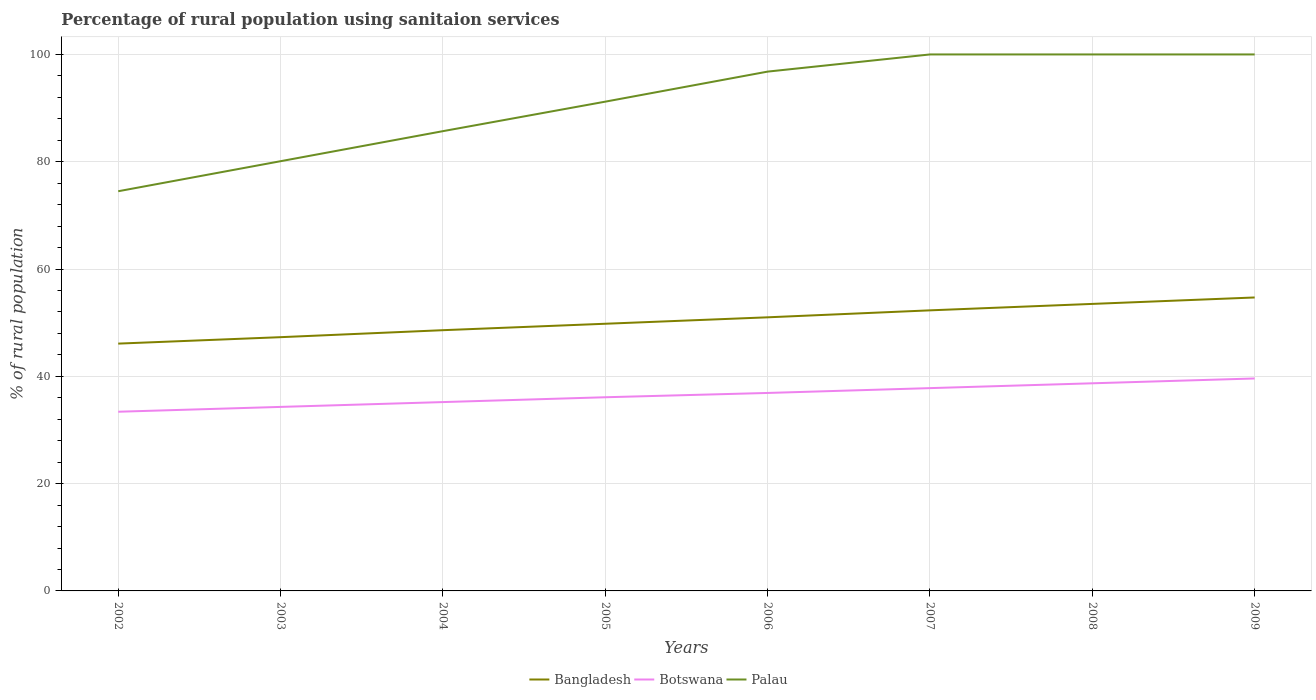How many different coloured lines are there?
Provide a succinct answer. 3. Is the number of lines equal to the number of legend labels?
Ensure brevity in your answer.  Yes. Across all years, what is the maximum percentage of rural population using sanitaion services in Bangladesh?
Provide a short and direct response. 46.1. In which year was the percentage of rural population using sanitaion services in Bangladesh maximum?
Offer a terse response. 2002. What is the total percentage of rural population using sanitaion services in Palau in the graph?
Your answer should be compact. -14.3. What is the difference between the highest and the lowest percentage of rural population using sanitaion services in Botswana?
Give a very brief answer. 4. Is the percentage of rural population using sanitaion services in Palau strictly greater than the percentage of rural population using sanitaion services in Bangladesh over the years?
Your answer should be very brief. No. Does the graph contain any zero values?
Offer a terse response. No. Where does the legend appear in the graph?
Your answer should be compact. Bottom center. How many legend labels are there?
Your answer should be very brief. 3. How are the legend labels stacked?
Offer a terse response. Horizontal. What is the title of the graph?
Your answer should be compact. Percentage of rural population using sanitaion services. Does "Ethiopia" appear as one of the legend labels in the graph?
Offer a very short reply. No. What is the label or title of the X-axis?
Keep it short and to the point. Years. What is the label or title of the Y-axis?
Offer a very short reply. % of rural population. What is the % of rural population of Bangladesh in 2002?
Offer a very short reply. 46.1. What is the % of rural population of Botswana in 2002?
Provide a succinct answer. 33.4. What is the % of rural population of Palau in 2002?
Your answer should be very brief. 74.5. What is the % of rural population of Bangladesh in 2003?
Your response must be concise. 47.3. What is the % of rural population of Botswana in 2003?
Give a very brief answer. 34.3. What is the % of rural population in Palau in 2003?
Provide a short and direct response. 80.1. What is the % of rural population of Bangladesh in 2004?
Your answer should be compact. 48.6. What is the % of rural population in Botswana in 2004?
Make the answer very short. 35.2. What is the % of rural population in Palau in 2004?
Provide a short and direct response. 85.7. What is the % of rural population in Bangladesh in 2005?
Provide a short and direct response. 49.8. What is the % of rural population of Botswana in 2005?
Your answer should be very brief. 36.1. What is the % of rural population in Palau in 2005?
Give a very brief answer. 91.2. What is the % of rural population of Botswana in 2006?
Your answer should be compact. 36.9. What is the % of rural population of Palau in 2006?
Your answer should be compact. 96.8. What is the % of rural population of Bangladesh in 2007?
Your answer should be compact. 52.3. What is the % of rural population in Botswana in 2007?
Give a very brief answer. 37.8. What is the % of rural population in Bangladesh in 2008?
Give a very brief answer. 53.5. What is the % of rural population in Botswana in 2008?
Give a very brief answer. 38.7. What is the % of rural population of Bangladesh in 2009?
Ensure brevity in your answer.  54.7. What is the % of rural population of Botswana in 2009?
Offer a very short reply. 39.6. Across all years, what is the maximum % of rural population in Bangladesh?
Ensure brevity in your answer.  54.7. Across all years, what is the maximum % of rural population of Botswana?
Provide a short and direct response. 39.6. Across all years, what is the minimum % of rural population in Bangladesh?
Your answer should be very brief. 46.1. Across all years, what is the minimum % of rural population of Botswana?
Ensure brevity in your answer.  33.4. Across all years, what is the minimum % of rural population of Palau?
Make the answer very short. 74.5. What is the total % of rural population in Bangladesh in the graph?
Give a very brief answer. 403.3. What is the total % of rural population in Botswana in the graph?
Keep it short and to the point. 292. What is the total % of rural population of Palau in the graph?
Provide a succinct answer. 728.3. What is the difference between the % of rural population in Bangladesh in 2002 and that in 2003?
Keep it short and to the point. -1.2. What is the difference between the % of rural population of Botswana in 2002 and that in 2003?
Keep it short and to the point. -0.9. What is the difference between the % of rural population in Palau in 2002 and that in 2003?
Offer a very short reply. -5.6. What is the difference between the % of rural population in Palau in 2002 and that in 2004?
Your response must be concise. -11.2. What is the difference between the % of rural population in Palau in 2002 and that in 2005?
Provide a succinct answer. -16.7. What is the difference between the % of rural population of Bangladesh in 2002 and that in 2006?
Offer a terse response. -4.9. What is the difference between the % of rural population of Botswana in 2002 and that in 2006?
Provide a short and direct response. -3.5. What is the difference between the % of rural population of Palau in 2002 and that in 2006?
Make the answer very short. -22.3. What is the difference between the % of rural population of Botswana in 2002 and that in 2007?
Your answer should be compact. -4.4. What is the difference between the % of rural population of Palau in 2002 and that in 2007?
Your response must be concise. -25.5. What is the difference between the % of rural population in Palau in 2002 and that in 2008?
Provide a succinct answer. -25.5. What is the difference between the % of rural population of Botswana in 2002 and that in 2009?
Provide a succinct answer. -6.2. What is the difference between the % of rural population of Palau in 2002 and that in 2009?
Your response must be concise. -25.5. What is the difference between the % of rural population in Bangladesh in 2003 and that in 2004?
Give a very brief answer. -1.3. What is the difference between the % of rural population of Bangladesh in 2003 and that in 2005?
Ensure brevity in your answer.  -2.5. What is the difference between the % of rural population in Botswana in 2003 and that in 2005?
Give a very brief answer. -1.8. What is the difference between the % of rural population in Palau in 2003 and that in 2005?
Keep it short and to the point. -11.1. What is the difference between the % of rural population of Palau in 2003 and that in 2006?
Provide a succinct answer. -16.7. What is the difference between the % of rural population of Botswana in 2003 and that in 2007?
Your answer should be compact. -3.5. What is the difference between the % of rural population in Palau in 2003 and that in 2007?
Provide a short and direct response. -19.9. What is the difference between the % of rural population of Botswana in 2003 and that in 2008?
Your response must be concise. -4.4. What is the difference between the % of rural population in Palau in 2003 and that in 2008?
Your answer should be compact. -19.9. What is the difference between the % of rural population in Bangladesh in 2003 and that in 2009?
Your answer should be compact. -7.4. What is the difference between the % of rural population of Palau in 2003 and that in 2009?
Provide a short and direct response. -19.9. What is the difference between the % of rural population in Botswana in 2004 and that in 2005?
Your answer should be very brief. -0.9. What is the difference between the % of rural population of Palau in 2004 and that in 2006?
Ensure brevity in your answer.  -11.1. What is the difference between the % of rural population of Bangladesh in 2004 and that in 2007?
Provide a short and direct response. -3.7. What is the difference between the % of rural population in Botswana in 2004 and that in 2007?
Your response must be concise. -2.6. What is the difference between the % of rural population in Palau in 2004 and that in 2007?
Your answer should be very brief. -14.3. What is the difference between the % of rural population in Bangladesh in 2004 and that in 2008?
Offer a very short reply. -4.9. What is the difference between the % of rural population in Palau in 2004 and that in 2008?
Offer a terse response. -14.3. What is the difference between the % of rural population of Bangladesh in 2004 and that in 2009?
Make the answer very short. -6.1. What is the difference between the % of rural population of Botswana in 2004 and that in 2009?
Give a very brief answer. -4.4. What is the difference between the % of rural population in Palau in 2004 and that in 2009?
Provide a short and direct response. -14.3. What is the difference between the % of rural population of Botswana in 2005 and that in 2006?
Your answer should be compact. -0.8. What is the difference between the % of rural population in Palau in 2005 and that in 2007?
Your answer should be very brief. -8.8. What is the difference between the % of rural population in Bangladesh in 2005 and that in 2008?
Make the answer very short. -3.7. What is the difference between the % of rural population in Botswana in 2005 and that in 2008?
Provide a short and direct response. -2.6. What is the difference between the % of rural population of Palau in 2005 and that in 2008?
Your answer should be compact. -8.8. What is the difference between the % of rural population in Botswana in 2005 and that in 2009?
Offer a very short reply. -3.5. What is the difference between the % of rural population of Palau in 2005 and that in 2009?
Give a very brief answer. -8.8. What is the difference between the % of rural population in Botswana in 2006 and that in 2007?
Provide a succinct answer. -0.9. What is the difference between the % of rural population in Botswana in 2006 and that in 2009?
Provide a succinct answer. -2.7. What is the difference between the % of rural population in Palau in 2006 and that in 2009?
Offer a terse response. -3.2. What is the difference between the % of rural population of Botswana in 2007 and that in 2008?
Offer a terse response. -0.9. What is the difference between the % of rural population of Palau in 2007 and that in 2008?
Ensure brevity in your answer.  0. What is the difference between the % of rural population of Bangladesh in 2002 and the % of rural population of Palau in 2003?
Provide a short and direct response. -34. What is the difference between the % of rural population of Botswana in 2002 and the % of rural population of Palau in 2003?
Provide a succinct answer. -46.7. What is the difference between the % of rural population in Bangladesh in 2002 and the % of rural population in Palau in 2004?
Provide a succinct answer. -39.6. What is the difference between the % of rural population in Botswana in 2002 and the % of rural population in Palau in 2004?
Keep it short and to the point. -52.3. What is the difference between the % of rural population in Bangladesh in 2002 and the % of rural population in Botswana in 2005?
Offer a very short reply. 10. What is the difference between the % of rural population in Bangladesh in 2002 and the % of rural population in Palau in 2005?
Give a very brief answer. -45.1. What is the difference between the % of rural population of Botswana in 2002 and the % of rural population of Palau in 2005?
Ensure brevity in your answer.  -57.8. What is the difference between the % of rural population of Bangladesh in 2002 and the % of rural population of Palau in 2006?
Your response must be concise. -50.7. What is the difference between the % of rural population of Botswana in 2002 and the % of rural population of Palau in 2006?
Your answer should be very brief. -63.4. What is the difference between the % of rural population in Bangladesh in 2002 and the % of rural population in Palau in 2007?
Your answer should be very brief. -53.9. What is the difference between the % of rural population in Botswana in 2002 and the % of rural population in Palau in 2007?
Provide a short and direct response. -66.6. What is the difference between the % of rural population in Bangladesh in 2002 and the % of rural population in Palau in 2008?
Keep it short and to the point. -53.9. What is the difference between the % of rural population of Botswana in 2002 and the % of rural population of Palau in 2008?
Provide a succinct answer. -66.6. What is the difference between the % of rural population in Bangladesh in 2002 and the % of rural population in Palau in 2009?
Give a very brief answer. -53.9. What is the difference between the % of rural population of Botswana in 2002 and the % of rural population of Palau in 2009?
Ensure brevity in your answer.  -66.6. What is the difference between the % of rural population in Bangladesh in 2003 and the % of rural population in Botswana in 2004?
Keep it short and to the point. 12.1. What is the difference between the % of rural population in Bangladesh in 2003 and the % of rural population in Palau in 2004?
Offer a very short reply. -38.4. What is the difference between the % of rural population in Botswana in 2003 and the % of rural population in Palau in 2004?
Your answer should be very brief. -51.4. What is the difference between the % of rural population in Bangladesh in 2003 and the % of rural population in Botswana in 2005?
Offer a very short reply. 11.2. What is the difference between the % of rural population of Bangladesh in 2003 and the % of rural population of Palau in 2005?
Provide a short and direct response. -43.9. What is the difference between the % of rural population in Botswana in 2003 and the % of rural population in Palau in 2005?
Your answer should be very brief. -56.9. What is the difference between the % of rural population in Bangladesh in 2003 and the % of rural population in Botswana in 2006?
Your response must be concise. 10.4. What is the difference between the % of rural population in Bangladesh in 2003 and the % of rural population in Palau in 2006?
Your answer should be compact. -49.5. What is the difference between the % of rural population in Botswana in 2003 and the % of rural population in Palau in 2006?
Provide a succinct answer. -62.5. What is the difference between the % of rural population of Bangladesh in 2003 and the % of rural population of Botswana in 2007?
Your response must be concise. 9.5. What is the difference between the % of rural population of Bangladesh in 2003 and the % of rural population of Palau in 2007?
Offer a terse response. -52.7. What is the difference between the % of rural population in Botswana in 2003 and the % of rural population in Palau in 2007?
Your response must be concise. -65.7. What is the difference between the % of rural population of Bangladesh in 2003 and the % of rural population of Palau in 2008?
Offer a very short reply. -52.7. What is the difference between the % of rural population of Botswana in 2003 and the % of rural population of Palau in 2008?
Give a very brief answer. -65.7. What is the difference between the % of rural population of Bangladesh in 2003 and the % of rural population of Botswana in 2009?
Give a very brief answer. 7.7. What is the difference between the % of rural population of Bangladesh in 2003 and the % of rural population of Palau in 2009?
Offer a very short reply. -52.7. What is the difference between the % of rural population in Botswana in 2003 and the % of rural population in Palau in 2009?
Your response must be concise. -65.7. What is the difference between the % of rural population in Bangladesh in 2004 and the % of rural population in Botswana in 2005?
Your answer should be compact. 12.5. What is the difference between the % of rural population in Bangladesh in 2004 and the % of rural population in Palau in 2005?
Keep it short and to the point. -42.6. What is the difference between the % of rural population in Botswana in 2004 and the % of rural population in Palau in 2005?
Give a very brief answer. -56. What is the difference between the % of rural population of Bangladesh in 2004 and the % of rural population of Palau in 2006?
Ensure brevity in your answer.  -48.2. What is the difference between the % of rural population of Botswana in 2004 and the % of rural population of Palau in 2006?
Make the answer very short. -61.6. What is the difference between the % of rural population of Bangladesh in 2004 and the % of rural population of Botswana in 2007?
Offer a terse response. 10.8. What is the difference between the % of rural population of Bangladesh in 2004 and the % of rural population of Palau in 2007?
Keep it short and to the point. -51.4. What is the difference between the % of rural population in Botswana in 2004 and the % of rural population in Palau in 2007?
Your answer should be very brief. -64.8. What is the difference between the % of rural population of Bangladesh in 2004 and the % of rural population of Palau in 2008?
Your answer should be compact. -51.4. What is the difference between the % of rural population of Botswana in 2004 and the % of rural population of Palau in 2008?
Ensure brevity in your answer.  -64.8. What is the difference between the % of rural population of Bangladesh in 2004 and the % of rural population of Botswana in 2009?
Provide a short and direct response. 9. What is the difference between the % of rural population of Bangladesh in 2004 and the % of rural population of Palau in 2009?
Your answer should be very brief. -51.4. What is the difference between the % of rural population of Botswana in 2004 and the % of rural population of Palau in 2009?
Provide a succinct answer. -64.8. What is the difference between the % of rural population of Bangladesh in 2005 and the % of rural population of Palau in 2006?
Your answer should be compact. -47. What is the difference between the % of rural population in Botswana in 2005 and the % of rural population in Palau in 2006?
Keep it short and to the point. -60.7. What is the difference between the % of rural population in Bangladesh in 2005 and the % of rural population in Palau in 2007?
Your response must be concise. -50.2. What is the difference between the % of rural population in Botswana in 2005 and the % of rural population in Palau in 2007?
Offer a very short reply. -63.9. What is the difference between the % of rural population of Bangladesh in 2005 and the % of rural population of Botswana in 2008?
Your response must be concise. 11.1. What is the difference between the % of rural population in Bangladesh in 2005 and the % of rural population in Palau in 2008?
Keep it short and to the point. -50.2. What is the difference between the % of rural population of Botswana in 2005 and the % of rural population of Palau in 2008?
Provide a short and direct response. -63.9. What is the difference between the % of rural population in Bangladesh in 2005 and the % of rural population in Botswana in 2009?
Your answer should be compact. 10.2. What is the difference between the % of rural population in Bangladesh in 2005 and the % of rural population in Palau in 2009?
Your answer should be very brief. -50.2. What is the difference between the % of rural population of Botswana in 2005 and the % of rural population of Palau in 2009?
Keep it short and to the point. -63.9. What is the difference between the % of rural population of Bangladesh in 2006 and the % of rural population of Palau in 2007?
Provide a short and direct response. -49. What is the difference between the % of rural population of Botswana in 2006 and the % of rural population of Palau in 2007?
Your answer should be compact. -63.1. What is the difference between the % of rural population in Bangladesh in 2006 and the % of rural population in Botswana in 2008?
Your answer should be very brief. 12.3. What is the difference between the % of rural population of Bangladesh in 2006 and the % of rural population of Palau in 2008?
Your response must be concise. -49. What is the difference between the % of rural population in Botswana in 2006 and the % of rural population in Palau in 2008?
Keep it short and to the point. -63.1. What is the difference between the % of rural population of Bangladesh in 2006 and the % of rural population of Botswana in 2009?
Your response must be concise. 11.4. What is the difference between the % of rural population in Bangladesh in 2006 and the % of rural population in Palau in 2009?
Your answer should be compact. -49. What is the difference between the % of rural population in Botswana in 2006 and the % of rural population in Palau in 2009?
Your response must be concise. -63.1. What is the difference between the % of rural population in Bangladesh in 2007 and the % of rural population in Botswana in 2008?
Offer a terse response. 13.6. What is the difference between the % of rural population in Bangladesh in 2007 and the % of rural population in Palau in 2008?
Make the answer very short. -47.7. What is the difference between the % of rural population in Botswana in 2007 and the % of rural population in Palau in 2008?
Offer a terse response. -62.2. What is the difference between the % of rural population of Bangladesh in 2007 and the % of rural population of Palau in 2009?
Your answer should be very brief. -47.7. What is the difference between the % of rural population in Botswana in 2007 and the % of rural population in Palau in 2009?
Make the answer very short. -62.2. What is the difference between the % of rural population in Bangladesh in 2008 and the % of rural population in Palau in 2009?
Keep it short and to the point. -46.5. What is the difference between the % of rural population of Botswana in 2008 and the % of rural population of Palau in 2009?
Ensure brevity in your answer.  -61.3. What is the average % of rural population of Bangladesh per year?
Offer a very short reply. 50.41. What is the average % of rural population in Botswana per year?
Ensure brevity in your answer.  36.5. What is the average % of rural population in Palau per year?
Provide a succinct answer. 91.04. In the year 2002, what is the difference between the % of rural population in Bangladesh and % of rural population in Palau?
Your response must be concise. -28.4. In the year 2002, what is the difference between the % of rural population of Botswana and % of rural population of Palau?
Your answer should be very brief. -41.1. In the year 2003, what is the difference between the % of rural population in Bangladesh and % of rural population in Botswana?
Provide a succinct answer. 13. In the year 2003, what is the difference between the % of rural population of Bangladesh and % of rural population of Palau?
Ensure brevity in your answer.  -32.8. In the year 2003, what is the difference between the % of rural population in Botswana and % of rural population in Palau?
Offer a very short reply. -45.8. In the year 2004, what is the difference between the % of rural population in Bangladesh and % of rural population in Palau?
Offer a terse response. -37.1. In the year 2004, what is the difference between the % of rural population in Botswana and % of rural population in Palau?
Your answer should be compact. -50.5. In the year 2005, what is the difference between the % of rural population of Bangladesh and % of rural population of Palau?
Your answer should be very brief. -41.4. In the year 2005, what is the difference between the % of rural population in Botswana and % of rural population in Palau?
Your response must be concise. -55.1. In the year 2006, what is the difference between the % of rural population of Bangladesh and % of rural population of Botswana?
Your response must be concise. 14.1. In the year 2006, what is the difference between the % of rural population of Bangladesh and % of rural population of Palau?
Ensure brevity in your answer.  -45.8. In the year 2006, what is the difference between the % of rural population in Botswana and % of rural population in Palau?
Keep it short and to the point. -59.9. In the year 2007, what is the difference between the % of rural population in Bangladesh and % of rural population in Palau?
Offer a terse response. -47.7. In the year 2007, what is the difference between the % of rural population of Botswana and % of rural population of Palau?
Make the answer very short. -62.2. In the year 2008, what is the difference between the % of rural population of Bangladesh and % of rural population of Botswana?
Make the answer very short. 14.8. In the year 2008, what is the difference between the % of rural population of Bangladesh and % of rural population of Palau?
Offer a terse response. -46.5. In the year 2008, what is the difference between the % of rural population of Botswana and % of rural population of Palau?
Give a very brief answer. -61.3. In the year 2009, what is the difference between the % of rural population in Bangladesh and % of rural population in Botswana?
Make the answer very short. 15.1. In the year 2009, what is the difference between the % of rural population of Bangladesh and % of rural population of Palau?
Provide a succinct answer. -45.3. In the year 2009, what is the difference between the % of rural population of Botswana and % of rural population of Palau?
Make the answer very short. -60.4. What is the ratio of the % of rural population in Bangladesh in 2002 to that in 2003?
Your answer should be very brief. 0.97. What is the ratio of the % of rural population of Botswana in 2002 to that in 2003?
Provide a succinct answer. 0.97. What is the ratio of the % of rural population of Palau in 2002 to that in 2003?
Your response must be concise. 0.93. What is the ratio of the % of rural population in Bangladesh in 2002 to that in 2004?
Your answer should be compact. 0.95. What is the ratio of the % of rural population of Botswana in 2002 to that in 2004?
Keep it short and to the point. 0.95. What is the ratio of the % of rural population of Palau in 2002 to that in 2004?
Provide a short and direct response. 0.87. What is the ratio of the % of rural population in Bangladesh in 2002 to that in 2005?
Your response must be concise. 0.93. What is the ratio of the % of rural population of Botswana in 2002 to that in 2005?
Provide a short and direct response. 0.93. What is the ratio of the % of rural population of Palau in 2002 to that in 2005?
Ensure brevity in your answer.  0.82. What is the ratio of the % of rural population in Bangladesh in 2002 to that in 2006?
Offer a very short reply. 0.9. What is the ratio of the % of rural population of Botswana in 2002 to that in 2006?
Keep it short and to the point. 0.91. What is the ratio of the % of rural population of Palau in 2002 to that in 2006?
Your response must be concise. 0.77. What is the ratio of the % of rural population of Bangladesh in 2002 to that in 2007?
Make the answer very short. 0.88. What is the ratio of the % of rural population of Botswana in 2002 to that in 2007?
Keep it short and to the point. 0.88. What is the ratio of the % of rural population in Palau in 2002 to that in 2007?
Keep it short and to the point. 0.74. What is the ratio of the % of rural population of Bangladesh in 2002 to that in 2008?
Keep it short and to the point. 0.86. What is the ratio of the % of rural population of Botswana in 2002 to that in 2008?
Give a very brief answer. 0.86. What is the ratio of the % of rural population in Palau in 2002 to that in 2008?
Give a very brief answer. 0.74. What is the ratio of the % of rural population of Bangladesh in 2002 to that in 2009?
Your response must be concise. 0.84. What is the ratio of the % of rural population in Botswana in 2002 to that in 2009?
Give a very brief answer. 0.84. What is the ratio of the % of rural population in Palau in 2002 to that in 2009?
Your answer should be compact. 0.74. What is the ratio of the % of rural population in Bangladesh in 2003 to that in 2004?
Ensure brevity in your answer.  0.97. What is the ratio of the % of rural population in Botswana in 2003 to that in 2004?
Keep it short and to the point. 0.97. What is the ratio of the % of rural population of Palau in 2003 to that in 2004?
Provide a succinct answer. 0.93. What is the ratio of the % of rural population of Bangladesh in 2003 to that in 2005?
Your answer should be very brief. 0.95. What is the ratio of the % of rural population of Botswana in 2003 to that in 2005?
Make the answer very short. 0.95. What is the ratio of the % of rural population in Palau in 2003 to that in 2005?
Give a very brief answer. 0.88. What is the ratio of the % of rural population of Bangladesh in 2003 to that in 2006?
Offer a very short reply. 0.93. What is the ratio of the % of rural population in Botswana in 2003 to that in 2006?
Provide a short and direct response. 0.93. What is the ratio of the % of rural population of Palau in 2003 to that in 2006?
Give a very brief answer. 0.83. What is the ratio of the % of rural population in Bangladesh in 2003 to that in 2007?
Offer a very short reply. 0.9. What is the ratio of the % of rural population of Botswana in 2003 to that in 2007?
Your answer should be compact. 0.91. What is the ratio of the % of rural population of Palau in 2003 to that in 2007?
Your answer should be very brief. 0.8. What is the ratio of the % of rural population of Bangladesh in 2003 to that in 2008?
Your answer should be very brief. 0.88. What is the ratio of the % of rural population of Botswana in 2003 to that in 2008?
Give a very brief answer. 0.89. What is the ratio of the % of rural population of Palau in 2003 to that in 2008?
Your answer should be compact. 0.8. What is the ratio of the % of rural population of Bangladesh in 2003 to that in 2009?
Provide a short and direct response. 0.86. What is the ratio of the % of rural population in Botswana in 2003 to that in 2009?
Make the answer very short. 0.87. What is the ratio of the % of rural population of Palau in 2003 to that in 2009?
Provide a succinct answer. 0.8. What is the ratio of the % of rural population of Bangladesh in 2004 to that in 2005?
Your answer should be very brief. 0.98. What is the ratio of the % of rural population of Botswana in 2004 to that in 2005?
Offer a very short reply. 0.98. What is the ratio of the % of rural population of Palau in 2004 to that in 2005?
Your response must be concise. 0.94. What is the ratio of the % of rural population of Bangladesh in 2004 to that in 2006?
Your answer should be compact. 0.95. What is the ratio of the % of rural population of Botswana in 2004 to that in 2006?
Your answer should be very brief. 0.95. What is the ratio of the % of rural population in Palau in 2004 to that in 2006?
Your response must be concise. 0.89. What is the ratio of the % of rural population in Bangladesh in 2004 to that in 2007?
Your response must be concise. 0.93. What is the ratio of the % of rural population of Botswana in 2004 to that in 2007?
Offer a very short reply. 0.93. What is the ratio of the % of rural population of Palau in 2004 to that in 2007?
Offer a terse response. 0.86. What is the ratio of the % of rural population of Bangladesh in 2004 to that in 2008?
Your answer should be compact. 0.91. What is the ratio of the % of rural population of Botswana in 2004 to that in 2008?
Offer a very short reply. 0.91. What is the ratio of the % of rural population in Palau in 2004 to that in 2008?
Provide a short and direct response. 0.86. What is the ratio of the % of rural population of Bangladesh in 2004 to that in 2009?
Offer a very short reply. 0.89. What is the ratio of the % of rural population in Palau in 2004 to that in 2009?
Give a very brief answer. 0.86. What is the ratio of the % of rural population in Bangladesh in 2005 to that in 2006?
Keep it short and to the point. 0.98. What is the ratio of the % of rural population in Botswana in 2005 to that in 2006?
Ensure brevity in your answer.  0.98. What is the ratio of the % of rural population in Palau in 2005 to that in 2006?
Make the answer very short. 0.94. What is the ratio of the % of rural population of Bangladesh in 2005 to that in 2007?
Your answer should be compact. 0.95. What is the ratio of the % of rural population of Botswana in 2005 to that in 2007?
Keep it short and to the point. 0.95. What is the ratio of the % of rural population in Palau in 2005 to that in 2007?
Ensure brevity in your answer.  0.91. What is the ratio of the % of rural population of Bangladesh in 2005 to that in 2008?
Your response must be concise. 0.93. What is the ratio of the % of rural population of Botswana in 2005 to that in 2008?
Give a very brief answer. 0.93. What is the ratio of the % of rural population of Palau in 2005 to that in 2008?
Your response must be concise. 0.91. What is the ratio of the % of rural population of Bangladesh in 2005 to that in 2009?
Your answer should be very brief. 0.91. What is the ratio of the % of rural population in Botswana in 2005 to that in 2009?
Provide a short and direct response. 0.91. What is the ratio of the % of rural population in Palau in 2005 to that in 2009?
Provide a short and direct response. 0.91. What is the ratio of the % of rural population of Bangladesh in 2006 to that in 2007?
Offer a very short reply. 0.98. What is the ratio of the % of rural population of Botswana in 2006 to that in 2007?
Make the answer very short. 0.98. What is the ratio of the % of rural population of Bangladesh in 2006 to that in 2008?
Keep it short and to the point. 0.95. What is the ratio of the % of rural population of Botswana in 2006 to that in 2008?
Keep it short and to the point. 0.95. What is the ratio of the % of rural population of Bangladesh in 2006 to that in 2009?
Your answer should be very brief. 0.93. What is the ratio of the % of rural population in Botswana in 2006 to that in 2009?
Give a very brief answer. 0.93. What is the ratio of the % of rural population of Palau in 2006 to that in 2009?
Your answer should be very brief. 0.97. What is the ratio of the % of rural population of Bangladesh in 2007 to that in 2008?
Your answer should be very brief. 0.98. What is the ratio of the % of rural population in Botswana in 2007 to that in 2008?
Offer a terse response. 0.98. What is the ratio of the % of rural population in Bangladesh in 2007 to that in 2009?
Your answer should be compact. 0.96. What is the ratio of the % of rural population of Botswana in 2007 to that in 2009?
Provide a short and direct response. 0.95. What is the ratio of the % of rural population in Bangladesh in 2008 to that in 2009?
Provide a short and direct response. 0.98. What is the ratio of the % of rural population in Botswana in 2008 to that in 2009?
Keep it short and to the point. 0.98. What is the difference between the highest and the second highest % of rural population in Botswana?
Your answer should be compact. 0.9. What is the difference between the highest and the second highest % of rural population of Palau?
Provide a short and direct response. 0. What is the difference between the highest and the lowest % of rural population of Botswana?
Give a very brief answer. 6.2. 